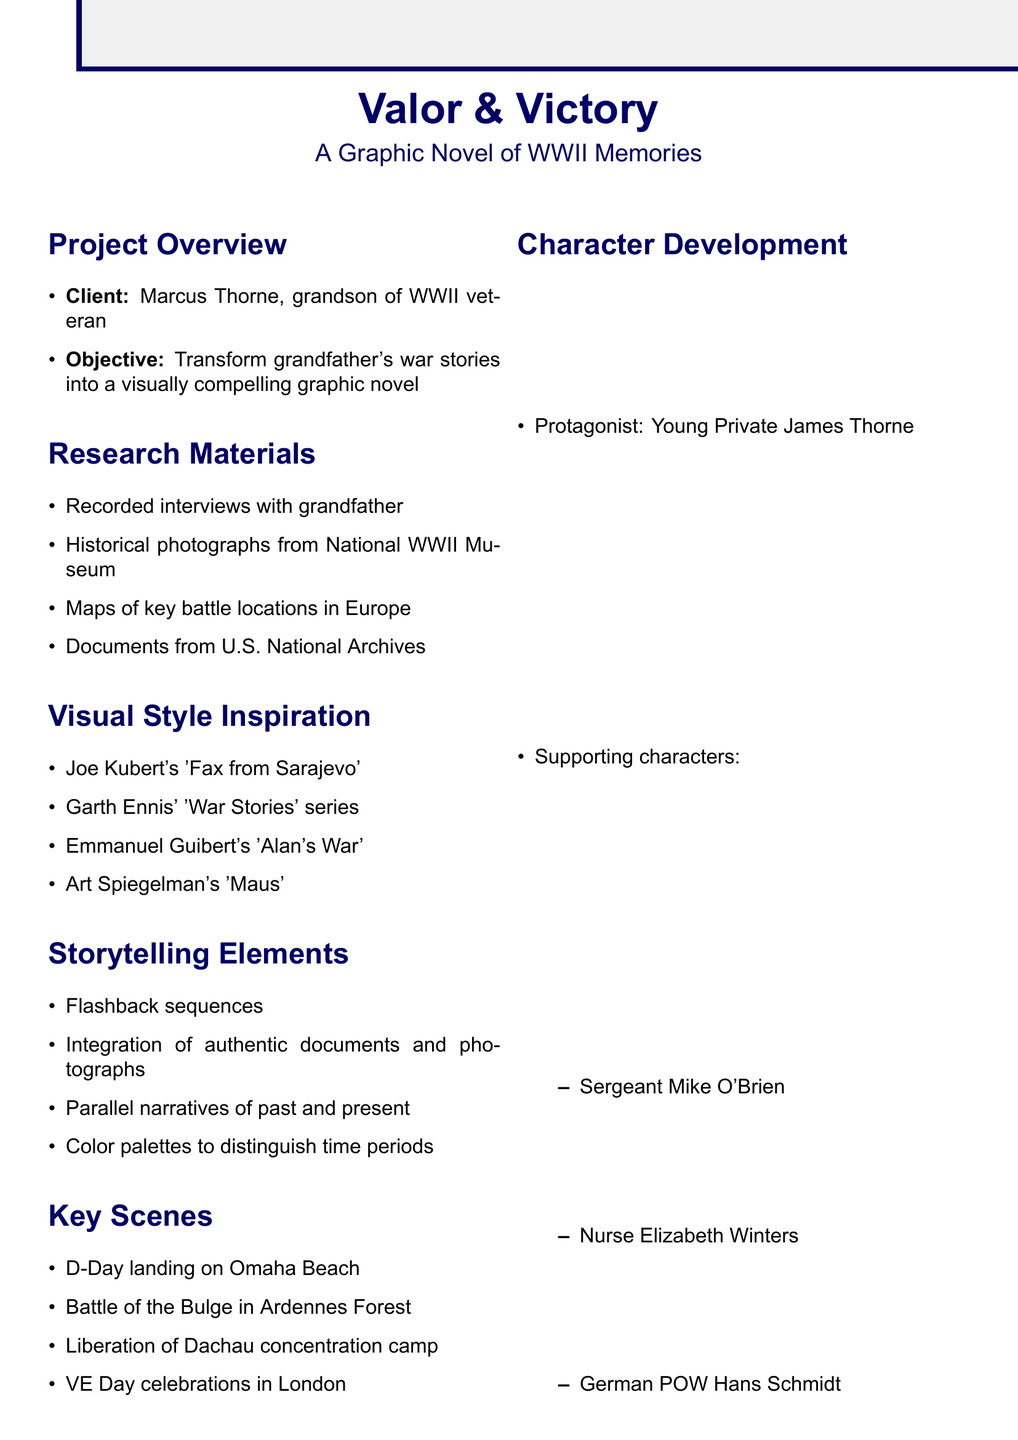What is the title of the graphic novel? The title is the first entry in the project overview section of the document.
Answer: Valor & Victory: A Graphic Novel of WWII Memories Who is the client for the project? The client is mentioned in the project overview section.
Answer: Marcus Thorne How many weeks are allocated for script development? The allocation for script development is listed under the production timeline section.
Answer: 6 weeks What is the page count of the graphic novel? The page count is specified in the technical specifications section.
Answer: 120 Which key scene involves the liberation of a camp? The key scenes section lists the liberation scene explicitly.
Answer: Dachau concentration camp What is one of the marketing strategies mentioned? The marketing strategies section includes various strategies for promoting the book.
Answer: Book signings at local veterans' organizations Who is the protagonist of the story? The protagonist's name is provided in the character development section.
Answer: Young Private James Thorne What color scheme is used for flashbacks? The color scheme for flashbacks is detailed in the technical specifications section.
Answer: Sepia tones What is one potential challenge in the project? Challenges are elaborated on in the potential challenges section of the document.
Answer: Balancing historical accuracy with storytelling 